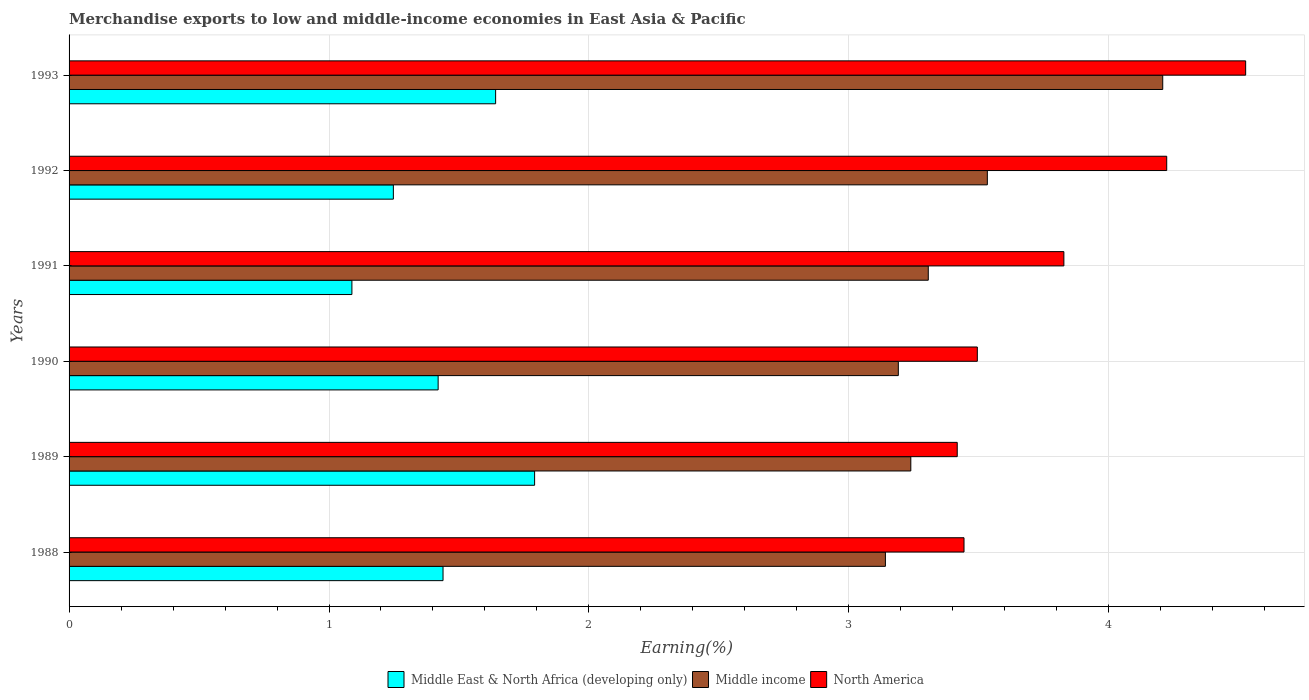How many different coloured bars are there?
Your response must be concise. 3. How many groups of bars are there?
Provide a succinct answer. 6. Are the number of bars per tick equal to the number of legend labels?
Give a very brief answer. Yes. How many bars are there on the 2nd tick from the bottom?
Ensure brevity in your answer.  3. In how many cases, is the number of bars for a given year not equal to the number of legend labels?
Make the answer very short. 0. What is the percentage of amount earned from merchandise exports in Middle East & North Africa (developing only) in 1990?
Your answer should be very brief. 1.42. Across all years, what is the maximum percentage of amount earned from merchandise exports in Middle East & North Africa (developing only)?
Your response must be concise. 1.79. Across all years, what is the minimum percentage of amount earned from merchandise exports in Middle income?
Ensure brevity in your answer.  3.14. In which year was the percentage of amount earned from merchandise exports in Middle income minimum?
Keep it short and to the point. 1988. What is the total percentage of amount earned from merchandise exports in Middle income in the graph?
Offer a terse response. 20.61. What is the difference between the percentage of amount earned from merchandise exports in Middle income in 1988 and that in 1990?
Ensure brevity in your answer.  -0.05. What is the difference between the percentage of amount earned from merchandise exports in Middle East & North Africa (developing only) in 1993 and the percentage of amount earned from merchandise exports in Middle income in 1991?
Your answer should be compact. -1.66. What is the average percentage of amount earned from merchandise exports in North America per year?
Provide a succinct answer. 3.82. In the year 1989, what is the difference between the percentage of amount earned from merchandise exports in Middle East & North Africa (developing only) and percentage of amount earned from merchandise exports in Middle income?
Provide a short and direct response. -1.45. In how many years, is the percentage of amount earned from merchandise exports in North America greater than 2.4 %?
Provide a succinct answer. 6. What is the ratio of the percentage of amount earned from merchandise exports in Middle East & North Africa (developing only) in 1991 to that in 1992?
Your answer should be very brief. 0.87. Is the percentage of amount earned from merchandise exports in North America in 1989 less than that in 1992?
Your answer should be compact. Yes. What is the difference between the highest and the second highest percentage of amount earned from merchandise exports in Middle income?
Ensure brevity in your answer.  0.67. What is the difference between the highest and the lowest percentage of amount earned from merchandise exports in Middle income?
Make the answer very short. 1.07. In how many years, is the percentage of amount earned from merchandise exports in North America greater than the average percentage of amount earned from merchandise exports in North America taken over all years?
Keep it short and to the point. 3. Are all the bars in the graph horizontal?
Your answer should be compact. Yes. What is the difference between two consecutive major ticks on the X-axis?
Your response must be concise. 1. Are the values on the major ticks of X-axis written in scientific E-notation?
Provide a succinct answer. No. Does the graph contain any zero values?
Your answer should be very brief. No. Does the graph contain grids?
Your answer should be very brief. Yes. Where does the legend appear in the graph?
Keep it short and to the point. Bottom center. How many legend labels are there?
Offer a terse response. 3. What is the title of the graph?
Provide a succinct answer. Merchandise exports to low and middle-income economies in East Asia & Pacific. Does "Czech Republic" appear as one of the legend labels in the graph?
Give a very brief answer. No. What is the label or title of the X-axis?
Ensure brevity in your answer.  Earning(%). What is the label or title of the Y-axis?
Your response must be concise. Years. What is the Earning(%) in Middle East & North Africa (developing only) in 1988?
Provide a short and direct response. 1.44. What is the Earning(%) in Middle income in 1988?
Your response must be concise. 3.14. What is the Earning(%) of North America in 1988?
Provide a succinct answer. 3.44. What is the Earning(%) of Middle East & North Africa (developing only) in 1989?
Provide a short and direct response. 1.79. What is the Earning(%) in Middle income in 1989?
Your answer should be very brief. 3.24. What is the Earning(%) in North America in 1989?
Provide a short and direct response. 3.42. What is the Earning(%) in Middle East & North Africa (developing only) in 1990?
Provide a short and direct response. 1.42. What is the Earning(%) in Middle income in 1990?
Your response must be concise. 3.19. What is the Earning(%) of North America in 1990?
Your response must be concise. 3.49. What is the Earning(%) in Middle East & North Africa (developing only) in 1991?
Give a very brief answer. 1.09. What is the Earning(%) in Middle income in 1991?
Ensure brevity in your answer.  3.31. What is the Earning(%) of North America in 1991?
Ensure brevity in your answer.  3.83. What is the Earning(%) in Middle East & North Africa (developing only) in 1992?
Offer a terse response. 1.25. What is the Earning(%) in Middle income in 1992?
Your answer should be compact. 3.53. What is the Earning(%) in North America in 1992?
Keep it short and to the point. 4.22. What is the Earning(%) of Middle East & North Africa (developing only) in 1993?
Ensure brevity in your answer.  1.64. What is the Earning(%) of Middle income in 1993?
Provide a succinct answer. 4.21. What is the Earning(%) in North America in 1993?
Give a very brief answer. 4.53. Across all years, what is the maximum Earning(%) in Middle East & North Africa (developing only)?
Your response must be concise. 1.79. Across all years, what is the maximum Earning(%) in Middle income?
Provide a succinct answer. 4.21. Across all years, what is the maximum Earning(%) in North America?
Offer a terse response. 4.53. Across all years, what is the minimum Earning(%) of Middle East & North Africa (developing only)?
Give a very brief answer. 1.09. Across all years, what is the minimum Earning(%) in Middle income?
Make the answer very short. 3.14. Across all years, what is the minimum Earning(%) in North America?
Keep it short and to the point. 3.42. What is the total Earning(%) in Middle East & North Africa (developing only) in the graph?
Offer a terse response. 8.63. What is the total Earning(%) in Middle income in the graph?
Give a very brief answer. 20.61. What is the total Earning(%) of North America in the graph?
Your answer should be compact. 22.93. What is the difference between the Earning(%) of Middle East & North Africa (developing only) in 1988 and that in 1989?
Ensure brevity in your answer.  -0.35. What is the difference between the Earning(%) in Middle income in 1988 and that in 1989?
Keep it short and to the point. -0.1. What is the difference between the Earning(%) of North America in 1988 and that in 1989?
Offer a very short reply. 0.03. What is the difference between the Earning(%) of Middle East & North Africa (developing only) in 1988 and that in 1990?
Your response must be concise. 0.02. What is the difference between the Earning(%) of Middle income in 1988 and that in 1990?
Make the answer very short. -0.05. What is the difference between the Earning(%) of North America in 1988 and that in 1990?
Ensure brevity in your answer.  -0.05. What is the difference between the Earning(%) in Middle East & North Africa (developing only) in 1988 and that in 1991?
Offer a very short reply. 0.35. What is the difference between the Earning(%) of Middle income in 1988 and that in 1991?
Provide a short and direct response. -0.16. What is the difference between the Earning(%) in North America in 1988 and that in 1991?
Give a very brief answer. -0.38. What is the difference between the Earning(%) of Middle East & North Africa (developing only) in 1988 and that in 1992?
Your response must be concise. 0.19. What is the difference between the Earning(%) of Middle income in 1988 and that in 1992?
Offer a terse response. -0.39. What is the difference between the Earning(%) in North America in 1988 and that in 1992?
Keep it short and to the point. -0.78. What is the difference between the Earning(%) of Middle East & North Africa (developing only) in 1988 and that in 1993?
Offer a very short reply. -0.2. What is the difference between the Earning(%) of Middle income in 1988 and that in 1993?
Give a very brief answer. -1.07. What is the difference between the Earning(%) of North America in 1988 and that in 1993?
Your response must be concise. -1.08. What is the difference between the Earning(%) in Middle East & North Africa (developing only) in 1989 and that in 1990?
Make the answer very short. 0.37. What is the difference between the Earning(%) of Middle income in 1989 and that in 1990?
Ensure brevity in your answer.  0.05. What is the difference between the Earning(%) of North America in 1989 and that in 1990?
Make the answer very short. -0.08. What is the difference between the Earning(%) in Middle East & North Africa (developing only) in 1989 and that in 1991?
Your answer should be very brief. 0.7. What is the difference between the Earning(%) in Middle income in 1989 and that in 1991?
Your answer should be very brief. -0.07. What is the difference between the Earning(%) in North America in 1989 and that in 1991?
Offer a very short reply. -0.41. What is the difference between the Earning(%) of Middle East & North Africa (developing only) in 1989 and that in 1992?
Offer a terse response. 0.54. What is the difference between the Earning(%) in Middle income in 1989 and that in 1992?
Offer a very short reply. -0.29. What is the difference between the Earning(%) of North America in 1989 and that in 1992?
Give a very brief answer. -0.81. What is the difference between the Earning(%) in Middle East & North Africa (developing only) in 1989 and that in 1993?
Your response must be concise. 0.15. What is the difference between the Earning(%) of Middle income in 1989 and that in 1993?
Keep it short and to the point. -0.97. What is the difference between the Earning(%) in North America in 1989 and that in 1993?
Give a very brief answer. -1.11. What is the difference between the Earning(%) of Middle East & North Africa (developing only) in 1990 and that in 1991?
Keep it short and to the point. 0.33. What is the difference between the Earning(%) in Middle income in 1990 and that in 1991?
Your response must be concise. -0.12. What is the difference between the Earning(%) of North America in 1990 and that in 1991?
Your answer should be compact. -0.33. What is the difference between the Earning(%) in Middle East & North Africa (developing only) in 1990 and that in 1992?
Offer a very short reply. 0.17. What is the difference between the Earning(%) in Middle income in 1990 and that in 1992?
Your answer should be compact. -0.34. What is the difference between the Earning(%) in North America in 1990 and that in 1992?
Your answer should be very brief. -0.73. What is the difference between the Earning(%) in Middle East & North Africa (developing only) in 1990 and that in 1993?
Offer a terse response. -0.22. What is the difference between the Earning(%) of Middle income in 1990 and that in 1993?
Offer a very short reply. -1.02. What is the difference between the Earning(%) in North America in 1990 and that in 1993?
Ensure brevity in your answer.  -1.03. What is the difference between the Earning(%) in Middle East & North Africa (developing only) in 1991 and that in 1992?
Your answer should be compact. -0.16. What is the difference between the Earning(%) in Middle income in 1991 and that in 1992?
Give a very brief answer. -0.23. What is the difference between the Earning(%) of North America in 1991 and that in 1992?
Offer a terse response. -0.4. What is the difference between the Earning(%) of Middle East & North Africa (developing only) in 1991 and that in 1993?
Offer a very short reply. -0.55. What is the difference between the Earning(%) of Middle income in 1991 and that in 1993?
Offer a terse response. -0.9. What is the difference between the Earning(%) in North America in 1991 and that in 1993?
Your answer should be compact. -0.7. What is the difference between the Earning(%) in Middle East & North Africa (developing only) in 1992 and that in 1993?
Your response must be concise. -0.39. What is the difference between the Earning(%) in Middle income in 1992 and that in 1993?
Make the answer very short. -0.67. What is the difference between the Earning(%) in North America in 1992 and that in 1993?
Provide a short and direct response. -0.3. What is the difference between the Earning(%) in Middle East & North Africa (developing only) in 1988 and the Earning(%) in Middle income in 1989?
Give a very brief answer. -1.8. What is the difference between the Earning(%) of Middle East & North Africa (developing only) in 1988 and the Earning(%) of North America in 1989?
Provide a succinct answer. -1.98. What is the difference between the Earning(%) of Middle income in 1988 and the Earning(%) of North America in 1989?
Your answer should be compact. -0.28. What is the difference between the Earning(%) of Middle East & North Africa (developing only) in 1988 and the Earning(%) of Middle income in 1990?
Provide a short and direct response. -1.75. What is the difference between the Earning(%) in Middle East & North Africa (developing only) in 1988 and the Earning(%) in North America in 1990?
Your answer should be very brief. -2.06. What is the difference between the Earning(%) in Middle income in 1988 and the Earning(%) in North America in 1990?
Your answer should be compact. -0.35. What is the difference between the Earning(%) in Middle East & North Africa (developing only) in 1988 and the Earning(%) in Middle income in 1991?
Offer a terse response. -1.87. What is the difference between the Earning(%) of Middle East & North Africa (developing only) in 1988 and the Earning(%) of North America in 1991?
Ensure brevity in your answer.  -2.39. What is the difference between the Earning(%) in Middle income in 1988 and the Earning(%) in North America in 1991?
Your answer should be compact. -0.69. What is the difference between the Earning(%) in Middle East & North Africa (developing only) in 1988 and the Earning(%) in Middle income in 1992?
Your response must be concise. -2.09. What is the difference between the Earning(%) in Middle East & North Africa (developing only) in 1988 and the Earning(%) in North America in 1992?
Ensure brevity in your answer.  -2.78. What is the difference between the Earning(%) of Middle income in 1988 and the Earning(%) of North America in 1992?
Provide a succinct answer. -1.08. What is the difference between the Earning(%) of Middle East & North Africa (developing only) in 1988 and the Earning(%) of Middle income in 1993?
Your answer should be very brief. -2.77. What is the difference between the Earning(%) in Middle East & North Africa (developing only) in 1988 and the Earning(%) in North America in 1993?
Ensure brevity in your answer.  -3.09. What is the difference between the Earning(%) in Middle income in 1988 and the Earning(%) in North America in 1993?
Provide a succinct answer. -1.39. What is the difference between the Earning(%) in Middle East & North Africa (developing only) in 1989 and the Earning(%) in Middle income in 1990?
Offer a terse response. -1.4. What is the difference between the Earning(%) in Middle East & North Africa (developing only) in 1989 and the Earning(%) in North America in 1990?
Your response must be concise. -1.7. What is the difference between the Earning(%) of Middle income in 1989 and the Earning(%) of North America in 1990?
Your answer should be very brief. -0.26. What is the difference between the Earning(%) of Middle East & North Africa (developing only) in 1989 and the Earning(%) of Middle income in 1991?
Your response must be concise. -1.51. What is the difference between the Earning(%) of Middle East & North Africa (developing only) in 1989 and the Earning(%) of North America in 1991?
Your response must be concise. -2.04. What is the difference between the Earning(%) of Middle income in 1989 and the Earning(%) of North America in 1991?
Offer a terse response. -0.59. What is the difference between the Earning(%) of Middle East & North Africa (developing only) in 1989 and the Earning(%) of Middle income in 1992?
Offer a terse response. -1.74. What is the difference between the Earning(%) of Middle East & North Africa (developing only) in 1989 and the Earning(%) of North America in 1992?
Ensure brevity in your answer.  -2.43. What is the difference between the Earning(%) in Middle income in 1989 and the Earning(%) in North America in 1992?
Offer a very short reply. -0.98. What is the difference between the Earning(%) of Middle East & North Africa (developing only) in 1989 and the Earning(%) of Middle income in 1993?
Ensure brevity in your answer.  -2.42. What is the difference between the Earning(%) of Middle East & North Africa (developing only) in 1989 and the Earning(%) of North America in 1993?
Keep it short and to the point. -2.74. What is the difference between the Earning(%) of Middle income in 1989 and the Earning(%) of North America in 1993?
Ensure brevity in your answer.  -1.29. What is the difference between the Earning(%) of Middle East & North Africa (developing only) in 1990 and the Earning(%) of Middle income in 1991?
Keep it short and to the point. -1.89. What is the difference between the Earning(%) of Middle East & North Africa (developing only) in 1990 and the Earning(%) of North America in 1991?
Keep it short and to the point. -2.41. What is the difference between the Earning(%) of Middle income in 1990 and the Earning(%) of North America in 1991?
Your response must be concise. -0.64. What is the difference between the Earning(%) of Middle East & North Africa (developing only) in 1990 and the Earning(%) of Middle income in 1992?
Offer a terse response. -2.11. What is the difference between the Earning(%) of Middle East & North Africa (developing only) in 1990 and the Earning(%) of North America in 1992?
Your response must be concise. -2.8. What is the difference between the Earning(%) in Middle income in 1990 and the Earning(%) in North America in 1992?
Your answer should be very brief. -1.03. What is the difference between the Earning(%) of Middle East & North Africa (developing only) in 1990 and the Earning(%) of Middle income in 1993?
Your answer should be compact. -2.79. What is the difference between the Earning(%) in Middle East & North Africa (developing only) in 1990 and the Earning(%) in North America in 1993?
Offer a terse response. -3.11. What is the difference between the Earning(%) of Middle income in 1990 and the Earning(%) of North America in 1993?
Ensure brevity in your answer.  -1.34. What is the difference between the Earning(%) of Middle East & North Africa (developing only) in 1991 and the Earning(%) of Middle income in 1992?
Give a very brief answer. -2.44. What is the difference between the Earning(%) in Middle East & North Africa (developing only) in 1991 and the Earning(%) in North America in 1992?
Your answer should be compact. -3.13. What is the difference between the Earning(%) of Middle income in 1991 and the Earning(%) of North America in 1992?
Provide a succinct answer. -0.92. What is the difference between the Earning(%) of Middle East & North Africa (developing only) in 1991 and the Earning(%) of Middle income in 1993?
Ensure brevity in your answer.  -3.12. What is the difference between the Earning(%) in Middle East & North Africa (developing only) in 1991 and the Earning(%) in North America in 1993?
Provide a succinct answer. -3.44. What is the difference between the Earning(%) of Middle income in 1991 and the Earning(%) of North America in 1993?
Make the answer very short. -1.22. What is the difference between the Earning(%) in Middle East & North Africa (developing only) in 1992 and the Earning(%) in Middle income in 1993?
Your answer should be compact. -2.96. What is the difference between the Earning(%) of Middle East & North Africa (developing only) in 1992 and the Earning(%) of North America in 1993?
Your response must be concise. -3.28. What is the difference between the Earning(%) in Middle income in 1992 and the Earning(%) in North America in 1993?
Provide a succinct answer. -0.99. What is the average Earning(%) in Middle East & North Africa (developing only) per year?
Keep it short and to the point. 1.44. What is the average Earning(%) in Middle income per year?
Your answer should be compact. 3.44. What is the average Earning(%) of North America per year?
Your answer should be very brief. 3.82. In the year 1988, what is the difference between the Earning(%) in Middle East & North Africa (developing only) and Earning(%) in Middle income?
Provide a succinct answer. -1.7. In the year 1988, what is the difference between the Earning(%) in Middle East & North Africa (developing only) and Earning(%) in North America?
Provide a short and direct response. -2. In the year 1988, what is the difference between the Earning(%) in Middle income and Earning(%) in North America?
Provide a short and direct response. -0.3. In the year 1989, what is the difference between the Earning(%) in Middle East & North Africa (developing only) and Earning(%) in Middle income?
Make the answer very short. -1.45. In the year 1989, what is the difference between the Earning(%) of Middle East & North Africa (developing only) and Earning(%) of North America?
Your answer should be compact. -1.63. In the year 1989, what is the difference between the Earning(%) in Middle income and Earning(%) in North America?
Provide a short and direct response. -0.18. In the year 1990, what is the difference between the Earning(%) in Middle East & North Africa (developing only) and Earning(%) in Middle income?
Your answer should be compact. -1.77. In the year 1990, what is the difference between the Earning(%) of Middle East & North Africa (developing only) and Earning(%) of North America?
Ensure brevity in your answer.  -2.07. In the year 1990, what is the difference between the Earning(%) of Middle income and Earning(%) of North America?
Offer a very short reply. -0.3. In the year 1991, what is the difference between the Earning(%) in Middle East & North Africa (developing only) and Earning(%) in Middle income?
Provide a short and direct response. -2.22. In the year 1991, what is the difference between the Earning(%) in Middle East & North Africa (developing only) and Earning(%) in North America?
Offer a very short reply. -2.74. In the year 1991, what is the difference between the Earning(%) of Middle income and Earning(%) of North America?
Your answer should be compact. -0.52. In the year 1992, what is the difference between the Earning(%) in Middle East & North Africa (developing only) and Earning(%) in Middle income?
Offer a terse response. -2.29. In the year 1992, what is the difference between the Earning(%) of Middle East & North Africa (developing only) and Earning(%) of North America?
Provide a short and direct response. -2.98. In the year 1992, what is the difference between the Earning(%) of Middle income and Earning(%) of North America?
Provide a short and direct response. -0.69. In the year 1993, what is the difference between the Earning(%) in Middle East & North Africa (developing only) and Earning(%) in Middle income?
Provide a short and direct response. -2.57. In the year 1993, what is the difference between the Earning(%) in Middle East & North Africa (developing only) and Earning(%) in North America?
Provide a succinct answer. -2.89. In the year 1993, what is the difference between the Earning(%) in Middle income and Earning(%) in North America?
Provide a succinct answer. -0.32. What is the ratio of the Earning(%) in Middle East & North Africa (developing only) in 1988 to that in 1989?
Make the answer very short. 0.8. What is the ratio of the Earning(%) of Middle income in 1988 to that in 1989?
Offer a terse response. 0.97. What is the ratio of the Earning(%) of North America in 1988 to that in 1989?
Provide a short and direct response. 1.01. What is the ratio of the Earning(%) of Middle East & North Africa (developing only) in 1988 to that in 1990?
Provide a succinct answer. 1.01. What is the ratio of the Earning(%) of Middle income in 1988 to that in 1990?
Your answer should be very brief. 0.98. What is the ratio of the Earning(%) in Middle East & North Africa (developing only) in 1988 to that in 1991?
Ensure brevity in your answer.  1.32. What is the ratio of the Earning(%) in Middle income in 1988 to that in 1991?
Your answer should be very brief. 0.95. What is the ratio of the Earning(%) in North America in 1988 to that in 1991?
Provide a short and direct response. 0.9. What is the ratio of the Earning(%) in Middle East & North Africa (developing only) in 1988 to that in 1992?
Offer a very short reply. 1.15. What is the ratio of the Earning(%) of Middle income in 1988 to that in 1992?
Ensure brevity in your answer.  0.89. What is the ratio of the Earning(%) in North America in 1988 to that in 1992?
Provide a succinct answer. 0.82. What is the ratio of the Earning(%) in Middle East & North Africa (developing only) in 1988 to that in 1993?
Provide a short and direct response. 0.88. What is the ratio of the Earning(%) in Middle income in 1988 to that in 1993?
Ensure brevity in your answer.  0.75. What is the ratio of the Earning(%) of North America in 1988 to that in 1993?
Offer a very short reply. 0.76. What is the ratio of the Earning(%) of Middle East & North Africa (developing only) in 1989 to that in 1990?
Give a very brief answer. 1.26. What is the ratio of the Earning(%) of Middle income in 1989 to that in 1990?
Make the answer very short. 1.02. What is the ratio of the Earning(%) in North America in 1989 to that in 1990?
Your response must be concise. 0.98. What is the ratio of the Earning(%) in Middle East & North Africa (developing only) in 1989 to that in 1991?
Ensure brevity in your answer.  1.65. What is the ratio of the Earning(%) in Middle income in 1989 to that in 1991?
Provide a succinct answer. 0.98. What is the ratio of the Earning(%) of North America in 1989 to that in 1991?
Ensure brevity in your answer.  0.89. What is the ratio of the Earning(%) of Middle East & North Africa (developing only) in 1989 to that in 1992?
Offer a terse response. 1.44. What is the ratio of the Earning(%) in North America in 1989 to that in 1992?
Ensure brevity in your answer.  0.81. What is the ratio of the Earning(%) in Middle East & North Africa (developing only) in 1989 to that in 1993?
Your answer should be compact. 1.09. What is the ratio of the Earning(%) in Middle income in 1989 to that in 1993?
Provide a succinct answer. 0.77. What is the ratio of the Earning(%) of North America in 1989 to that in 1993?
Your response must be concise. 0.75. What is the ratio of the Earning(%) in Middle East & North Africa (developing only) in 1990 to that in 1991?
Offer a very short reply. 1.3. What is the ratio of the Earning(%) in Middle income in 1990 to that in 1991?
Give a very brief answer. 0.97. What is the ratio of the Earning(%) in North America in 1990 to that in 1991?
Your response must be concise. 0.91. What is the ratio of the Earning(%) of Middle East & North Africa (developing only) in 1990 to that in 1992?
Keep it short and to the point. 1.14. What is the ratio of the Earning(%) of Middle income in 1990 to that in 1992?
Ensure brevity in your answer.  0.9. What is the ratio of the Earning(%) of North America in 1990 to that in 1992?
Your answer should be very brief. 0.83. What is the ratio of the Earning(%) in Middle East & North Africa (developing only) in 1990 to that in 1993?
Keep it short and to the point. 0.87. What is the ratio of the Earning(%) of Middle income in 1990 to that in 1993?
Offer a very short reply. 0.76. What is the ratio of the Earning(%) in North America in 1990 to that in 1993?
Your response must be concise. 0.77. What is the ratio of the Earning(%) in Middle East & North Africa (developing only) in 1991 to that in 1992?
Provide a succinct answer. 0.87. What is the ratio of the Earning(%) of Middle income in 1991 to that in 1992?
Ensure brevity in your answer.  0.94. What is the ratio of the Earning(%) of North America in 1991 to that in 1992?
Your answer should be very brief. 0.91. What is the ratio of the Earning(%) of Middle East & North Africa (developing only) in 1991 to that in 1993?
Make the answer very short. 0.66. What is the ratio of the Earning(%) of Middle income in 1991 to that in 1993?
Give a very brief answer. 0.79. What is the ratio of the Earning(%) of North America in 1991 to that in 1993?
Ensure brevity in your answer.  0.85. What is the ratio of the Earning(%) in Middle East & North Africa (developing only) in 1992 to that in 1993?
Ensure brevity in your answer.  0.76. What is the ratio of the Earning(%) of Middle income in 1992 to that in 1993?
Make the answer very short. 0.84. What is the ratio of the Earning(%) of North America in 1992 to that in 1993?
Provide a succinct answer. 0.93. What is the difference between the highest and the second highest Earning(%) in Middle East & North Africa (developing only)?
Ensure brevity in your answer.  0.15. What is the difference between the highest and the second highest Earning(%) in Middle income?
Give a very brief answer. 0.67. What is the difference between the highest and the second highest Earning(%) in North America?
Offer a very short reply. 0.3. What is the difference between the highest and the lowest Earning(%) of Middle East & North Africa (developing only)?
Offer a terse response. 0.7. What is the difference between the highest and the lowest Earning(%) in Middle income?
Give a very brief answer. 1.07. What is the difference between the highest and the lowest Earning(%) in North America?
Your answer should be very brief. 1.11. 